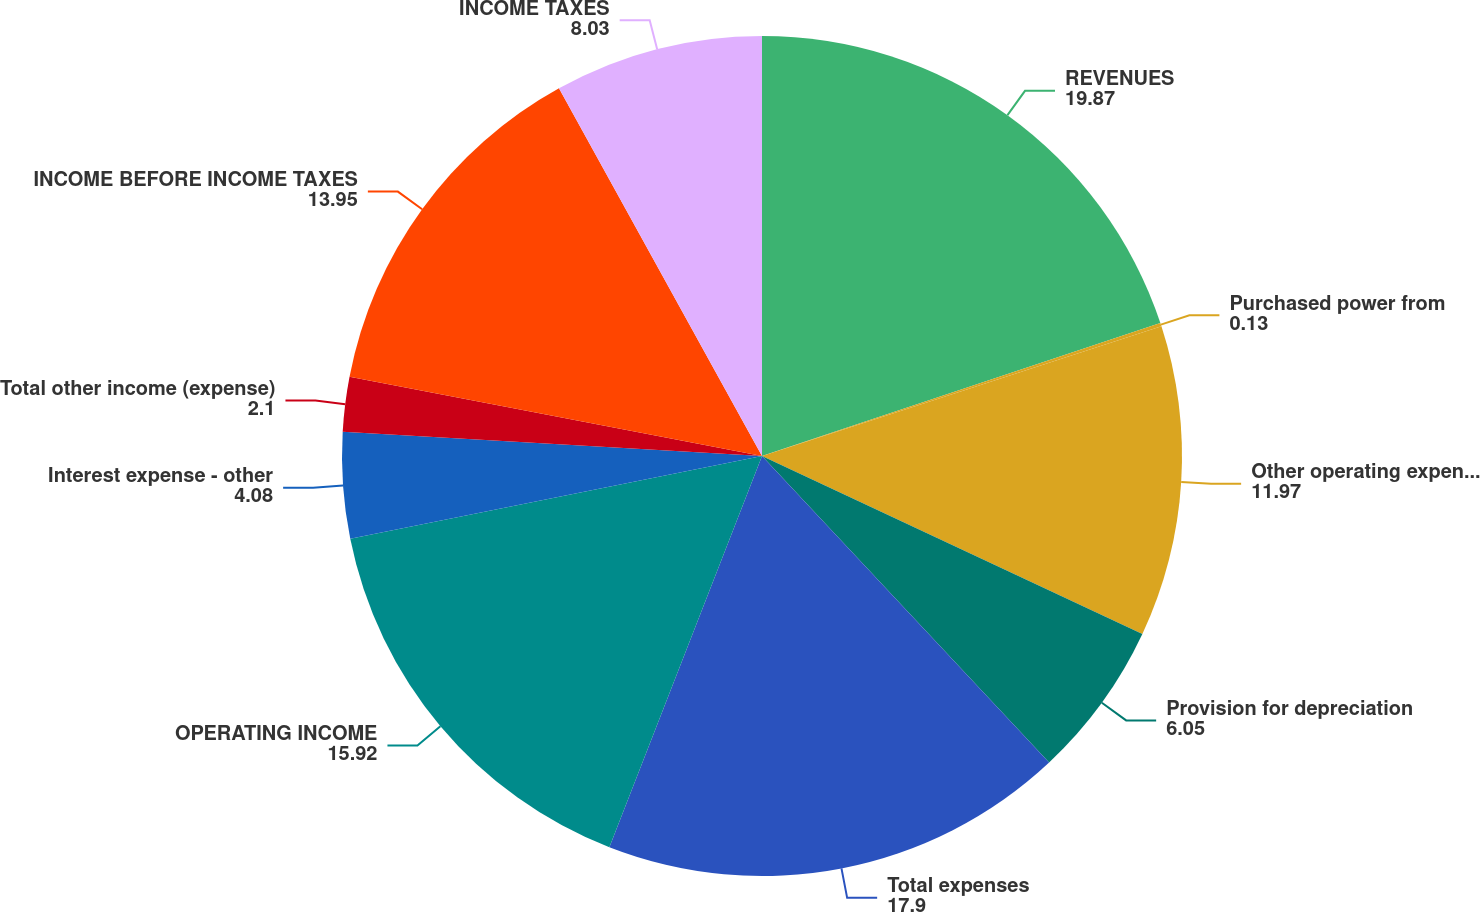<chart> <loc_0><loc_0><loc_500><loc_500><pie_chart><fcel>REVENUES<fcel>Purchased power from<fcel>Other operating expenses<fcel>Provision for depreciation<fcel>Total expenses<fcel>OPERATING INCOME<fcel>Interest expense - other<fcel>Total other income (expense)<fcel>INCOME BEFORE INCOME TAXES<fcel>INCOME TAXES<nl><fcel>19.87%<fcel>0.13%<fcel>11.97%<fcel>6.05%<fcel>17.9%<fcel>15.92%<fcel>4.08%<fcel>2.1%<fcel>13.95%<fcel>8.03%<nl></chart> 